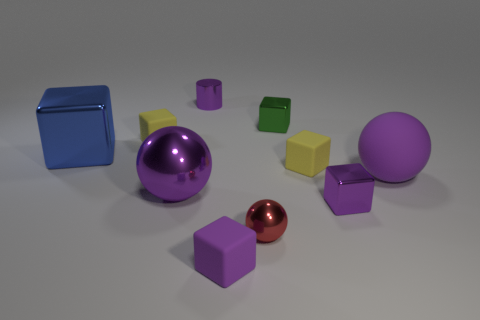What number of other objects are there of the same material as the small ball?
Your answer should be compact. 5. Do the metallic cylinder and the big object that is to the right of the small red ball have the same color?
Offer a terse response. Yes. The large cube has what color?
Offer a very short reply. Blue. What is the color of the other big metal object that is the same shape as the green metallic thing?
Offer a very short reply. Blue. Do the tiny red metallic thing and the big purple rubber object have the same shape?
Offer a terse response. Yes. What number of blocks are tiny purple objects or tiny purple rubber things?
Offer a terse response. 2. The large cube that is made of the same material as the tiny red ball is what color?
Make the answer very short. Blue. There is a purple matte block on the left side of the green object; is its size the same as the large blue metal object?
Keep it short and to the point. No. Are the small purple cylinder and the yellow thing that is left of the small green shiny block made of the same material?
Give a very brief answer. No. What color is the ball left of the tiny metal sphere?
Offer a terse response. Purple. 